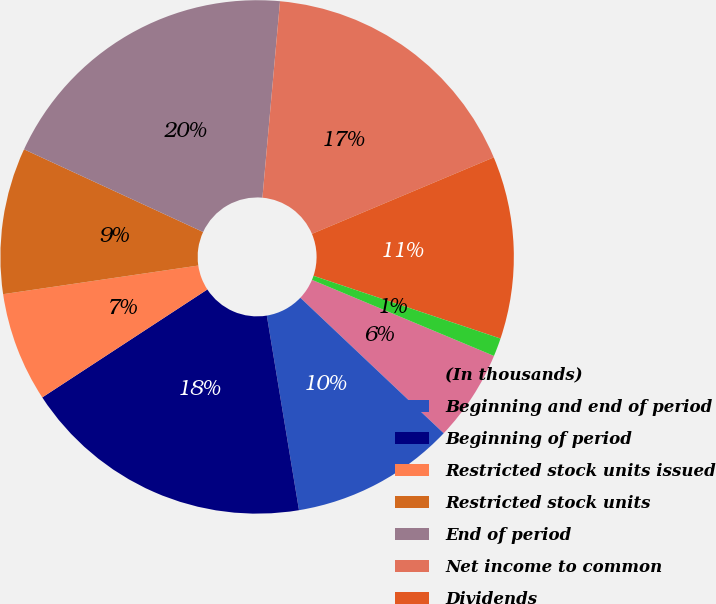Convert chart. <chart><loc_0><loc_0><loc_500><loc_500><pie_chart><fcel>(In thousands)<fcel>Beginning and end of period<fcel>Beginning of period<fcel>Restricted stock units issued<fcel>Restricted stock units<fcel>End of period<fcel>Net income to common<fcel>Dividends<fcel>Unrealized gains (losses) on<nl><fcel>5.75%<fcel>10.34%<fcel>18.39%<fcel>6.9%<fcel>9.2%<fcel>19.54%<fcel>17.24%<fcel>11.49%<fcel>1.15%<nl></chart> 